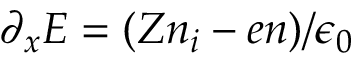Convert formula to latex. <formula><loc_0><loc_0><loc_500><loc_500>\partial _ { x } E = ( Z n _ { i } - e n ) / \epsilon _ { 0 }</formula> 